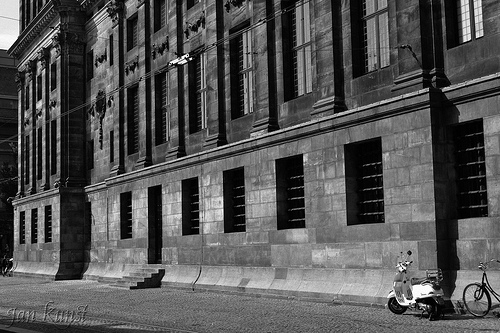Describe the overall atmosphere portrayed in the image. The image portrays a calm and quiet urban scene. The building's imposing and sturdy architecture gives a historic feel while the empty sidewalk suggests a moment of stillness. The presence of the bicycle and scooter adds a hint of everyday life and utility. 